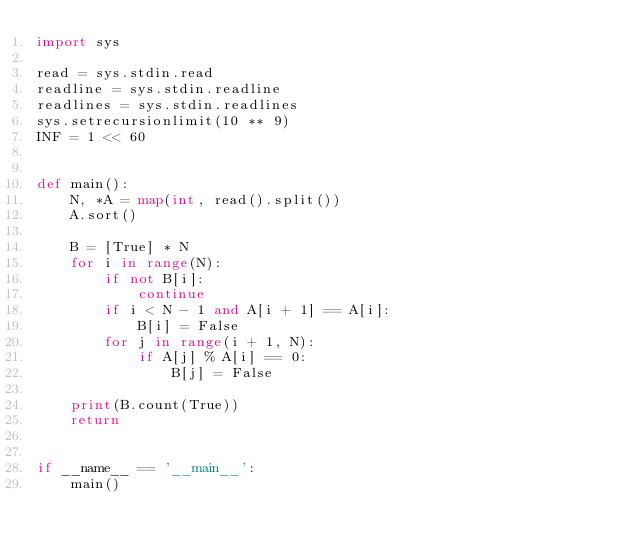Convert code to text. <code><loc_0><loc_0><loc_500><loc_500><_Python_>import sys

read = sys.stdin.read
readline = sys.stdin.readline
readlines = sys.stdin.readlines
sys.setrecursionlimit(10 ** 9)
INF = 1 << 60


def main():
    N, *A = map(int, read().split())
    A.sort()

    B = [True] * N
    for i in range(N):
        if not B[i]:
            continue
        if i < N - 1 and A[i + 1] == A[i]:
            B[i] = False
        for j in range(i + 1, N):
            if A[j] % A[i] == 0:
                B[j] = False

    print(B.count(True))
    return


if __name__ == '__main__':
    main()
</code> 